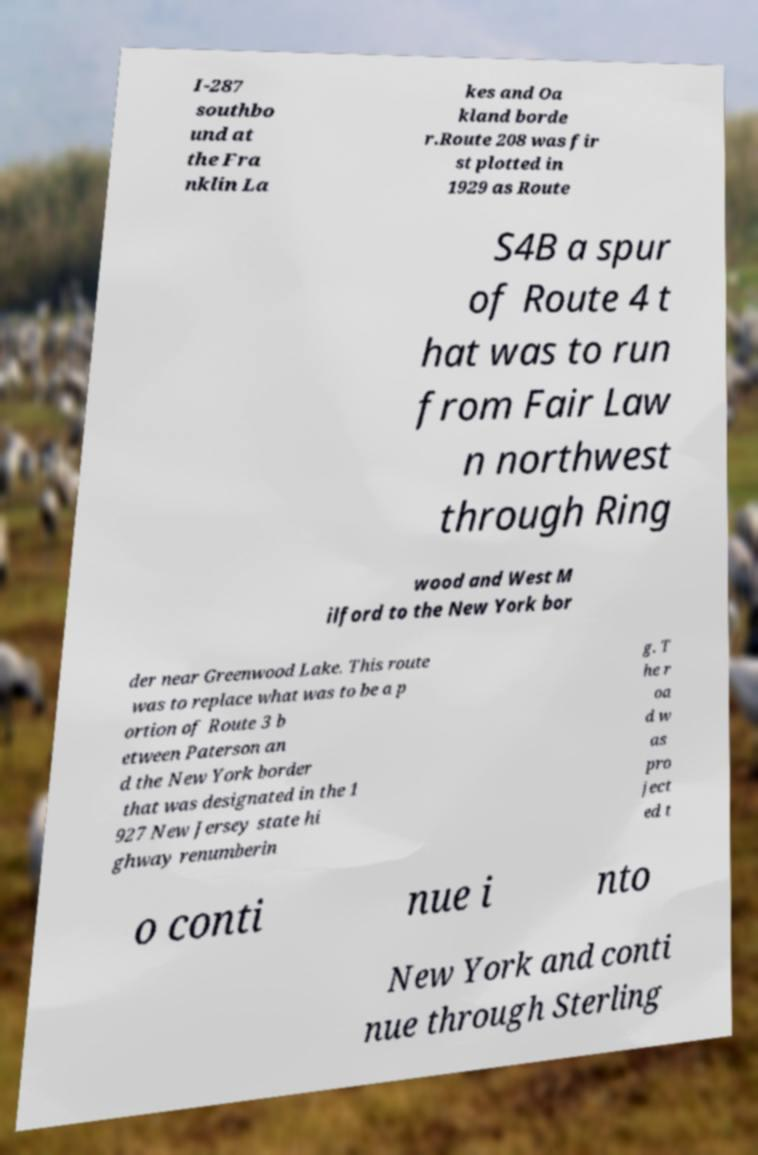Could you assist in decoding the text presented in this image and type it out clearly? I-287 southbo und at the Fra nklin La kes and Oa kland borde r.Route 208 was fir st plotted in 1929 as Route S4B a spur of Route 4 t hat was to run from Fair Law n northwest through Ring wood and West M ilford to the New York bor der near Greenwood Lake. This route was to replace what was to be a p ortion of Route 3 b etween Paterson an d the New York border that was designated in the 1 927 New Jersey state hi ghway renumberin g. T he r oa d w as pro ject ed t o conti nue i nto New York and conti nue through Sterling 